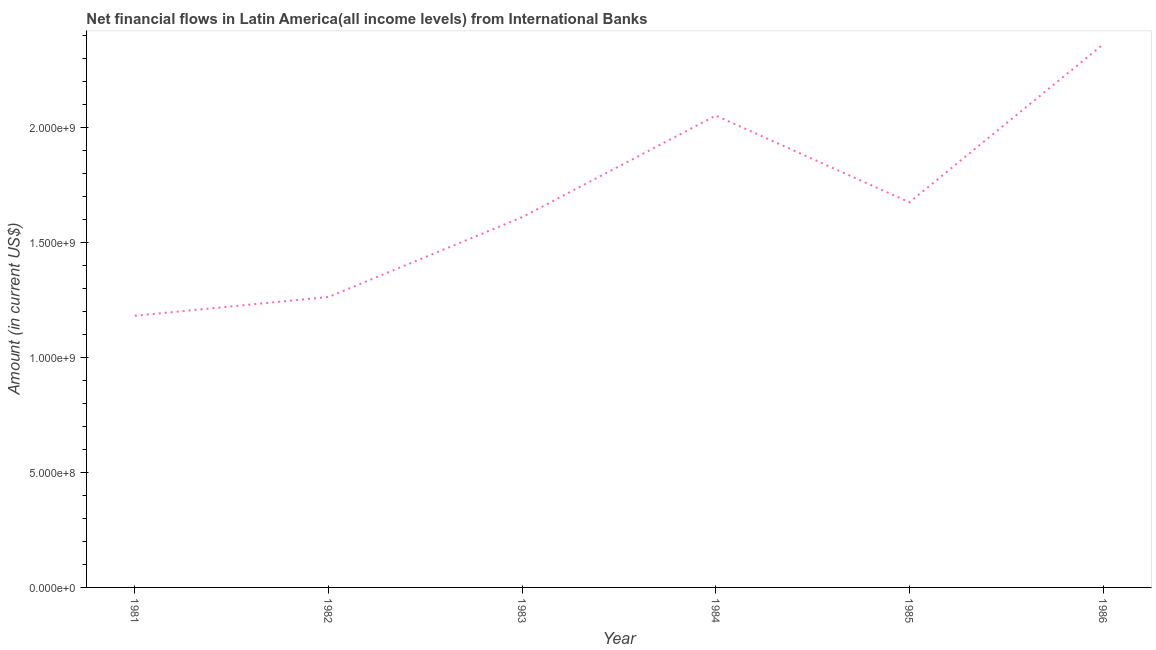What is the net financial flows from ibrd in 1986?
Your answer should be very brief. 2.36e+09. Across all years, what is the maximum net financial flows from ibrd?
Give a very brief answer. 2.36e+09. Across all years, what is the minimum net financial flows from ibrd?
Make the answer very short. 1.18e+09. What is the sum of the net financial flows from ibrd?
Provide a succinct answer. 1.01e+1. What is the difference between the net financial flows from ibrd in 1982 and 1984?
Provide a succinct answer. -7.89e+08. What is the average net financial flows from ibrd per year?
Provide a succinct answer. 1.69e+09. What is the median net financial flows from ibrd?
Offer a terse response. 1.64e+09. In how many years, is the net financial flows from ibrd greater than 900000000 US$?
Provide a succinct answer. 6. Do a majority of the years between 1982 and 1981 (inclusive) have net financial flows from ibrd greater than 2200000000 US$?
Your response must be concise. No. What is the ratio of the net financial flows from ibrd in 1981 to that in 1986?
Keep it short and to the point. 0.5. Is the net financial flows from ibrd in 1981 less than that in 1982?
Provide a short and direct response. Yes. What is the difference between the highest and the second highest net financial flows from ibrd?
Provide a short and direct response. 3.10e+08. What is the difference between the highest and the lowest net financial flows from ibrd?
Make the answer very short. 1.18e+09. How many lines are there?
Give a very brief answer. 1. What is the difference between two consecutive major ticks on the Y-axis?
Provide a short and direct response. 5.00e+08. What is the title of the graph?
Offer a terse response. Net financial flows in Latin America(all income levels) from International Banks. What is the Amount (in current US$) in 1981?
Make the answer very short. 1.18e+09. What is the Amount (in current US$) of 1982?
Provide a succinct answer. 1.26e+09. What is the Amount (in current US$) of 1983?
Keep it short and to the point. 1.61e+09. What is the Amount (in current US$) in 1984?
Offer a very short reply. 2.05e+09. What is the Amount (in current US$) in 1985?
Ensure brevity in your answer.  1.68e+09. What is the Amount (in current US$) in 1986?
Your answer should be very brief. 2.36e+09. What is the difference between the Amount (in current US$) in 1981 and 1982?
Offer a very short reply. -8.17e+07. What is the difference between the Amount (in current US$) in 1981 and 1983?
Offer a very short reply. -4.29e+08. What is the difference between the Amount (in current US$) in 1981 and 1984?
Provide a short and direct response. -8.71e+08. What is the difference between the Amount (in current US$) in 1981 and 1985?
Give a very brief answer. -4.94e+08. What is the difference between the Amount (in current US$) in 1981 and 1986?
Your answer should be compact. -1.18e+09. What is the difference between the Amount (in current US$) in 1982 and 1983?
Provide a succinct answer. -3.47e+08. What is the difference between the Amount (in current US$) in 1982 and 1984?
Give a very brief answer. -7.89e+08. What is the difference between the Amount (in current US$) in 1982 and 1985?
Offer a very short reply. -4.12e+08. What is the difference between the Amount (in current US$) in 1982 and 1986?
Offer a very short reply. -1.10e+09. What is the difference between the Amount (in current US$) in 1983 and 1984?
Give a very brief answer. -4.42e+08. What is the difference between the Amount (in current US$) in 1983 and 1985?
Provide a short and direct response. -6.47e+07. What is the difference between the Amount (in current US$) in 1983 and 1986?
Your answer should be compact. -7.52e+08. What is the difference between the Amount (in current US$) in 1984 and 1985?
Provide a short and direct response. 3.77e+08. What is the difference between the Amount (in current US$) in 1984 and 1986?
Give a very brief answer. -3.10e+08. What is the difference between the Amount (in current US$) in 1985 and 1986?
Provide a succinct answer. -6.87e+08. What is the ratio of the Amount (in current US$) in 1981 to that in 1982?
Give a very brief answer. 0.94. What is the ratio of the Amount (in current US$) in 1981 to that in 1983?
Your answer should be very brief. 0.73. What is the ratio of the Amount (in current US$) in 1981 to that in 1984?
Give a very brief answer. 0.58. What is the ratio of the Amount (in current US$) in 1981 to that in 1985?
Make the answer very short. 0.7. What is the ratio of the Amount (in current US$) in 1981 to that in 1986?
Offer a terse response. 0.5. What is the ratio of the Amount (in current US$) in 1982 to that in 1983?
Keep it short and to the point. 0.78. What is the ratio of the Amount (in current US$) in 1982 to that in 1984?
Ensure brevity in your answer.  0.62. What is the ratio of the Amount (in current US$) in 1982 to that in 1985?
Keep it short and to the point. 0.75. What is the ratio of the Amount (in current US$) in 1982 to that in 1986?
Provide a succinct answer. 0.54. What is the ratio of the Amount (in current US$) in 1983 to that in 1984?
Provide a short and direct response. 0.79. What is the ratio of the Amount (in current US$) in 1983 to that in 1986?
Make the answer very short. 0.68. What is the ratio of the Amount (in current US$) in 1984 to that in 1985?
Give a very brief answer. 1.23. What is the ratio of the Amount (in current US$) in 1984 to that in 1986?
Make the answer very short. 0.87. What is the ratio of the Amount (in current US$) in 1985 to that in 1986?
Your response must be concise. 0.71. 